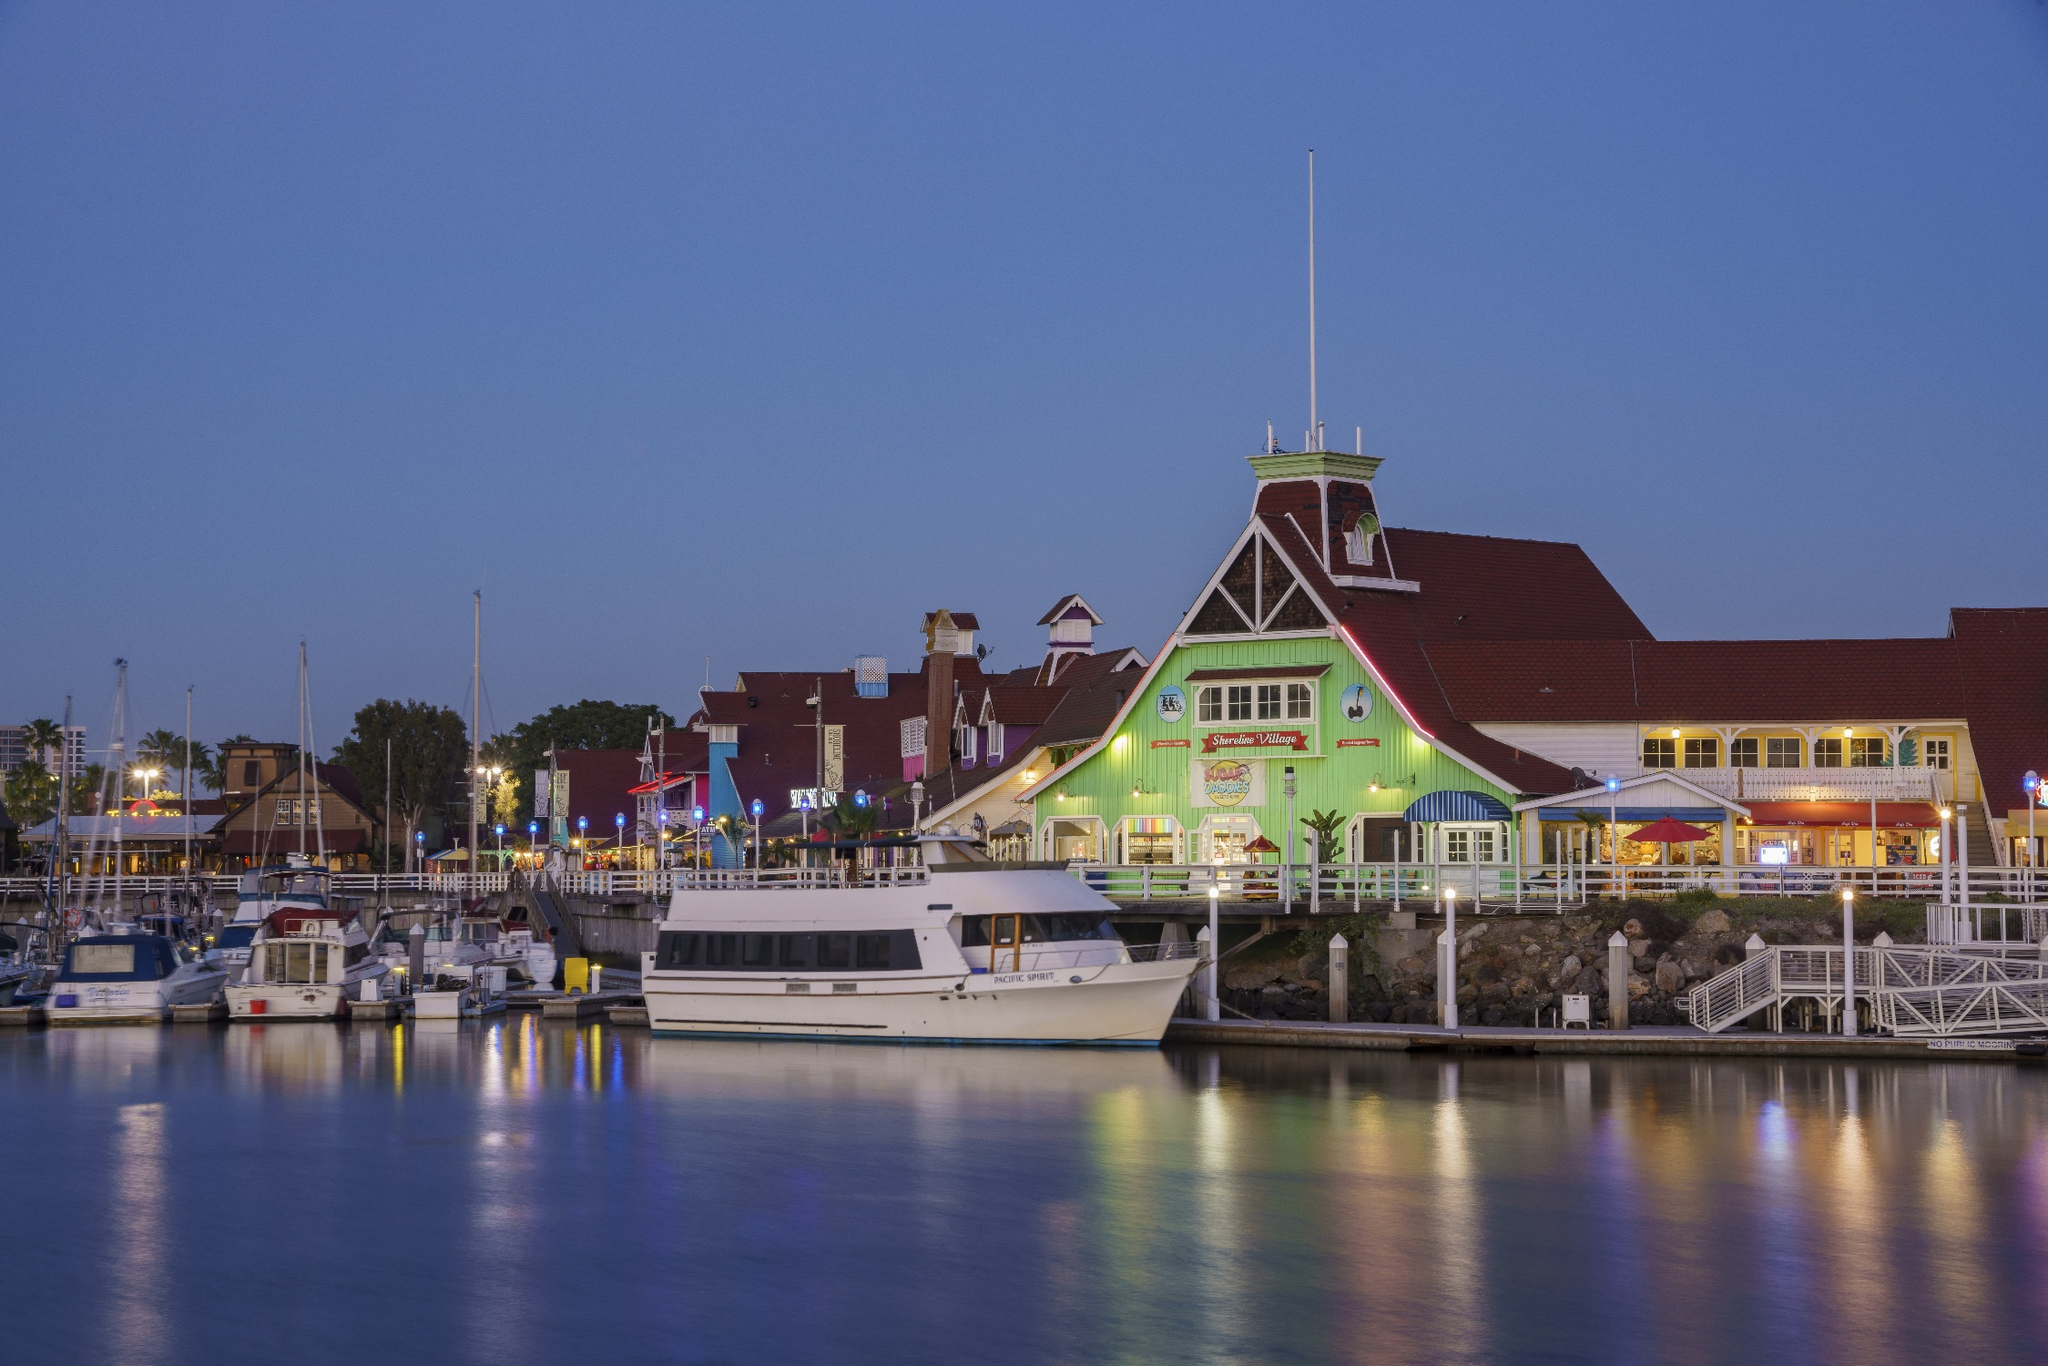What elements make this marina a popular destination for visitors? Several elements contribute to the popularity of the Long Beach Shoreline Marina. Firstly, the marina offers a beautiful and calm setting, perfect for enjoying boat rides and waterfront activities. The variety of boats and yachts moored at the docks provide a scenic and captivating view. Additionally, the marina is home to several iconic landmarks, such as Parkers' Lighthouse, known for its exceptional seafood and unique architecture. The vibrant lights and colorful buildings along the shoreline create a lively and inviting atmosphere, attracting both locals and tourists. Furthermore, the marina's prime location near entertainment venues, restaurants, and shopping areas makes it a convenient and attractive destination for visitors seeking both relaxation and entertainment. Could you describe a perfect evening spent at the marina? A perfect evening at the Long Beach Shoreline Marina begins with a leisurely stroll along the docks, taking in the cool, refreshing breeze and the beautiful array of boats gently swaying on the water. As the sun sets, the sky transitions to a mesmerizing palette of deep blues and purples, creating a stunning backdrop for the illuminated buildings along the shore. Diners can choose to enjoy a delicious meal at Parkers' Lighthouse, where they can indulge in fresh seafood while savoring the breathtaking views of the marina. The evening continues with a relaxing boat ride under the moonlit sky, offering a peaceful escape from the hustle and bustle. To cap off the night, visitors might grab a coffee or a dessert from one of the nearby cafes and sit by the water, reflecting on a truly memorable and tranquil evening. Imagine if the marina had a fantasy-themed event. What might it look like? If the Long Beach Shoreline Marina hosted a fantasy-themed event, it would transform into a magical realm straight out of a fairytale. The boats would be decorated as majestic galleons and mythical sea creatures like mermaids and krakens, with their sails and masts adorned with twinkling fairy lights. The shoreline buildings would be lit in vibrant hues, and enchanting music would waft through the air. Street performers dressed as wizards, elves, and other fantastical beings would entertain the visitors with captivating acts and stories. Food stalls would offer whimsical treats like dragonfire roasted meats, elven bread, and enchanted beverages. The highlight of the event would be a spectacular light and sound show, where holographic dragons and unicorns soar above the marina, accompanied by an epic musical score. This enchanting evening would leave everyone spellbound, creating unforgettable memories of a night filled with magic and wonder. 